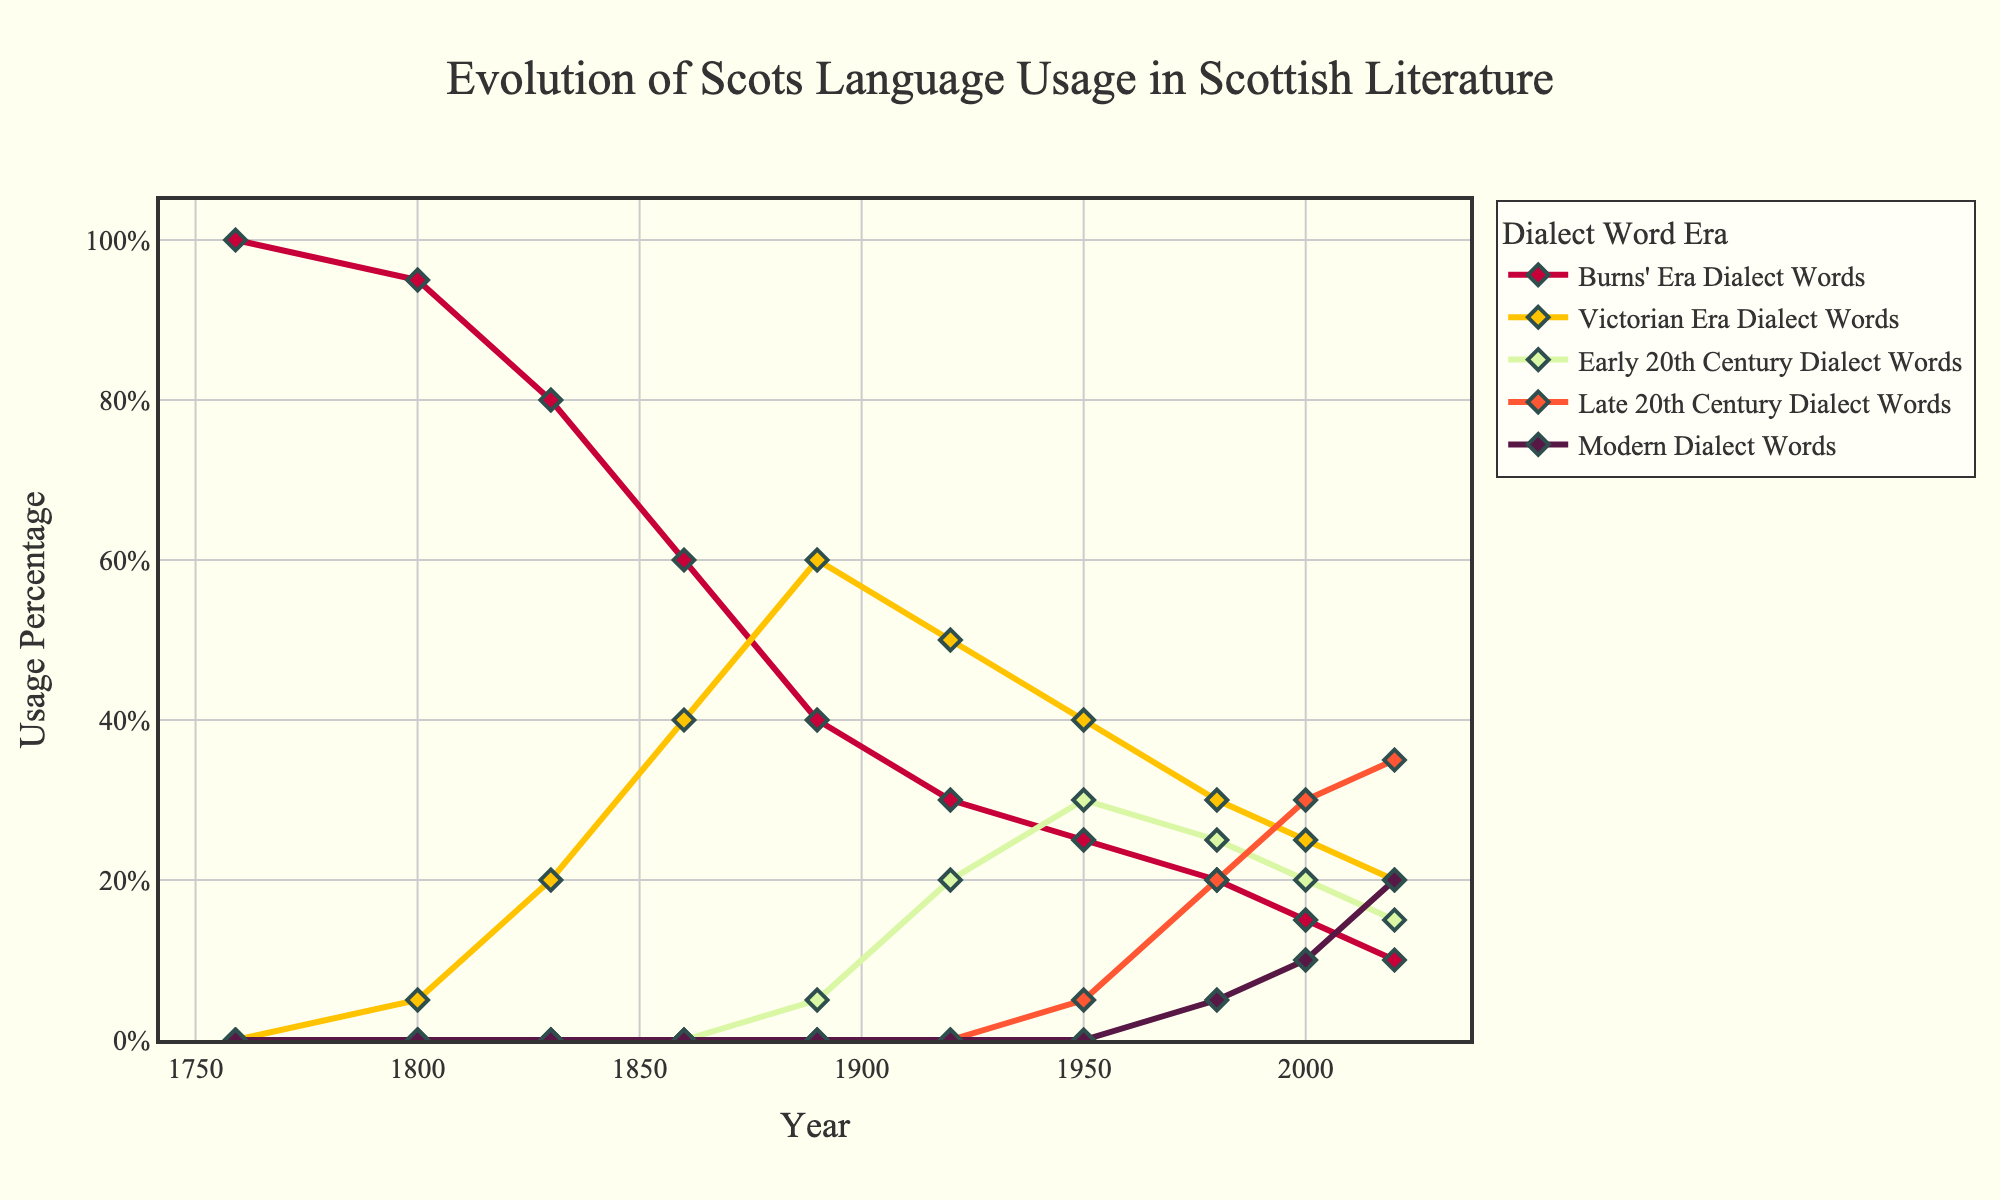What was the percentage usage of Burns' Era dialect words in 1800? From the legend and the line chart, locate the line corresponding to 'Burns' Era Dialect Words'. Follow this line to the year 1800 on the x-axis. The y-value corresponding to the year 1800 is 95%.
Answer: 95% How did the usage of Early 20th Century dialect words change from 1920 to 1950? Locate the line corresponding to 'Early 20th Century Dialect Words' in the legend. Follow this line from 1920 to 1950. In 1920, the usage was 20%, and in 1950, it increased to 30%. Thus, the change is an increase of 10%.
Answer: Increased by 10% Which dialect words had the highest percentage usage in 1980? Locate all the lines at the year 1980 on the x-axis. Compare their y-values. 'Victorian Era Dialect Words' had a usage of 30%, which is higher than any other category in that year.
Answer: Victorian Era Dialect Words Which category showed continuous growth in usage from 1950 to 2020? From the lines in the chart, 'Late 20th Century Dialect Words' consistently increases from 1950 (5%) to 2020 (35%).
Answer: Late 20th Century Dialect Words What is the sum of the usage percentages of Modern Dialect Words and Late 20th Century Dialect Words in 2020? Locate the lines corresponding to 'Modern Dialect Words' and 'Late 20th Century Dialect Words' for 2020. Their y-values are 20% and 35%, respectively. Sum these values: 20% + 35% = 55%.
Answer: 55% Which era's dialect words have seen the steepest decline from their peak to 2020? Locate the peak points and the values in 2020 for each category. 'Burns' Era Dialect Words' peaked at 100% and fell to 10% by 2020, reflecting a 90% decline, the steepest among the categories.
Answer: Burns' Era Dialect Words What is the difference in usage of Victorian Era Dialect Words between 1860 and 2020? For the 'Victorian Era Dialect Words', find the y-values at 1860 (40%) and 2020 (20%). The difference is 40% - 20% = 20%.
Answer: 20% In which year did Early 20th Century Dialect Words reach their peak usage? Observe the line corresponding to 'Early 20th Century Dialect Words' and identify where it reaches its highest point. The peak occurs in 1950 at 30%.
Answer: 1950 Compare the usage of Burns' Era Dialect Words and Victorian Era Dialect Words in 1920. Which was higher and by how much? Locate lines corresponding to 'Burns' Era Dialect Words' and 'Victorian Era Dialect Words' for 1920. The values are 30% and 50%, respectively. Victorian Era Dialect Words were higher by 50% - 30% = 20%.
Answer: Victorian Era Dialect Words by 20% What's the average usage percentage of Burns' Era Dialect Words from 1759 to 2020? Average is calculated by summing the values over the years and dividing by the number of years. Values: (100 + 95 + 80 + 60 + 40 + 30 + 25 + 20 + 15 + 10)/10 = 475/10 = 47.5%
Answer: 47.5% 